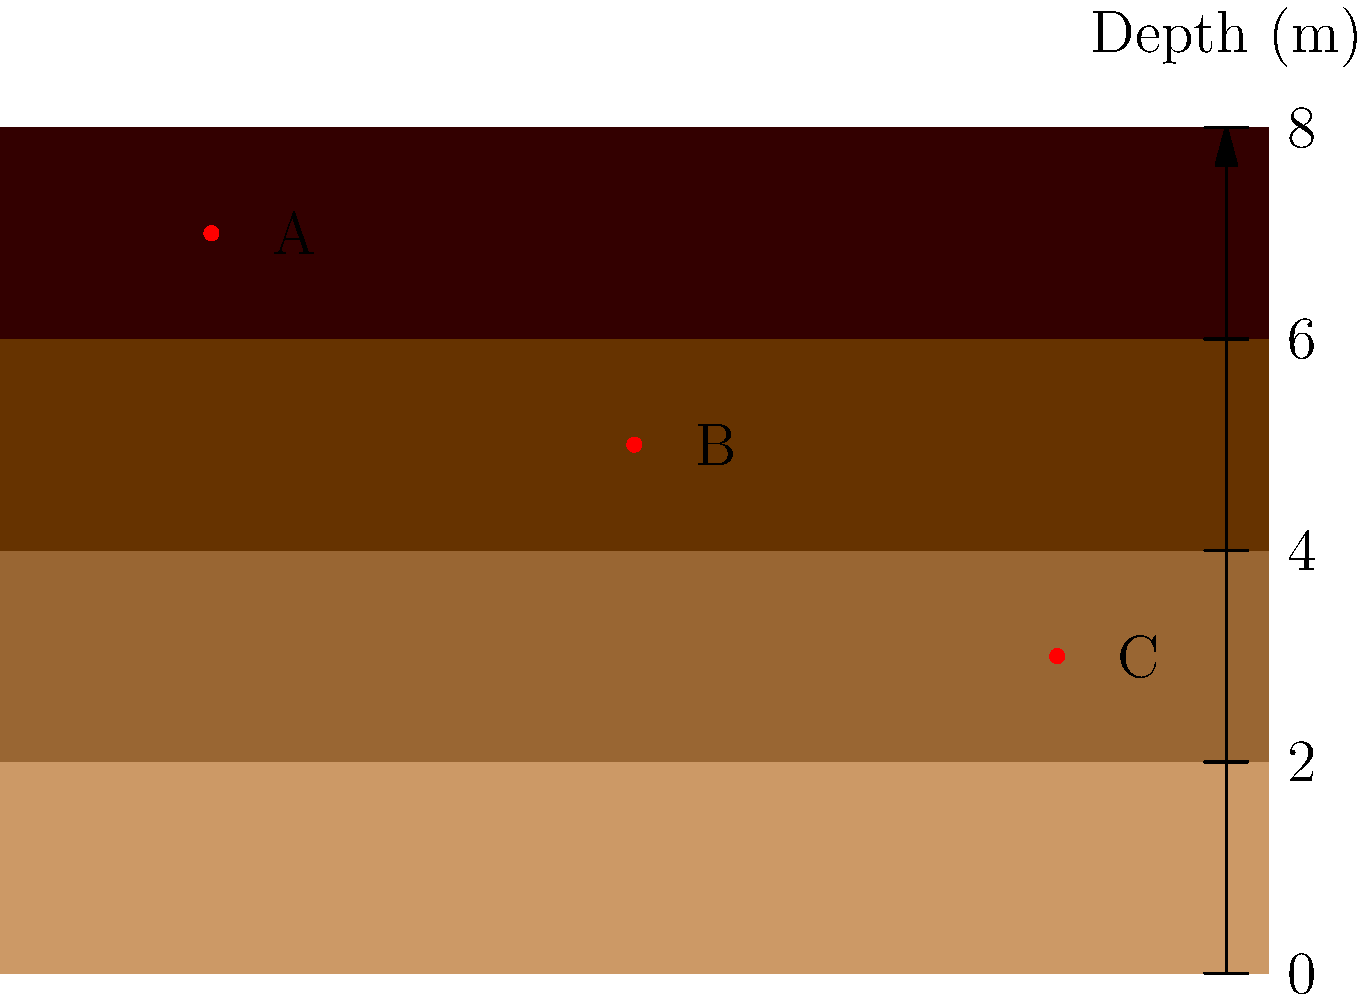Based on the geological strata shown in the diagram, which artifact (A, B, or C) is likely to be the oldest, assuming no disturbance in the layers? To determine the oldest artifact, we need to consider the principle of superposition in geology, which states that in undisturbed sedimentary layers, the oldest layers are at the bottom and the youngest at the top. Here's the step-by-step reasoning:

1. The diagram shows four distinct strata layers, with depth increasing from top to bottom.
2. Three artifacts (A, B, and C) are found at different depths within these layers.
3. Artifact A is located in the topmost layer, at approximately 0.5m depth.
4. Artifact B is in the second layer from the top, at about 1.5m depth.
5. Artifact C is in the third layer from the top, at approximately 2.5m depth.
6. Since deeper layers are older (assuming no disturbance), the artifact in the deepest layer is the oldest.
7. Among A, B, and C, artifact C is in the deepest layer.

Therefore, artifact C is likely to be the oldest.
Answer: C 